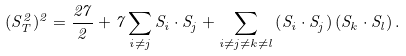Convert formula to latex. <formula><loc_0><loc_0><loc_500><loc_500>( S _ { T } ^ { 2 } ) ^ { 2 } = \frac { 2 7 } { 2 } + 7 \sum _ { i \neq j } S _ { i } \cdot S _ { j } + \sum _ { i \neq j \neq k \neq l } \left ( S _ { i } \cdot S _ { j } \right ) \left ( S _ { k } \cdot S _ { l } \right ) .</formula> 